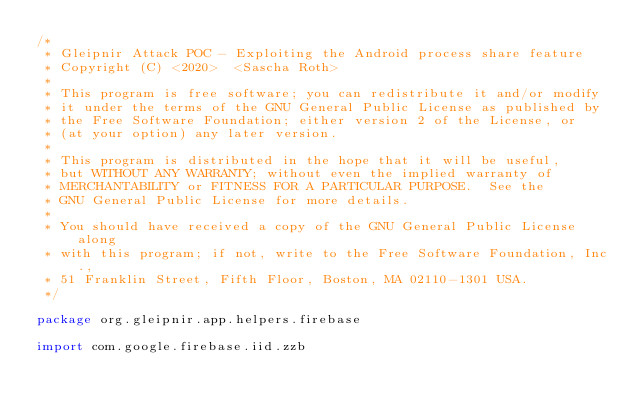<code> <loc_0><loc_0><loc_500><loc_500><_Kotlin_>/*
 * Gleipnir Attack POC - Exploiting the Android process share feature
 * Copyright (C) <2020>  <Sascha Roth>
 *
 * This program is free software; you can redistribute it and/or modify
 * it under the terms of the GNU General Public License as published by
 * the Free Software Foundation; either version 2 of the License, or
 * (at your option) any later version.
 *
 * This program is distributed in the hope that it will be useful,
 * but WITHOUT ANY WARRANTY; without even the implied warranty of
 * MERCHANTABILITY or FITNESS FOR A PARTICULAR PURPOSE.  See the
 * GNU General Public License for more details.
 *
 * You should have received a copy of the GNU General Public License along
 * with this program; if not, write to the Free Software Foundation, Inc.,
 * 51 Franklin Street, Fifth Floor, Boston, MA 02110-1301 USA.
 */

package org.gleipnir.app.helpers.firebase

import com.google.firebase.iid.zzb


</code> 